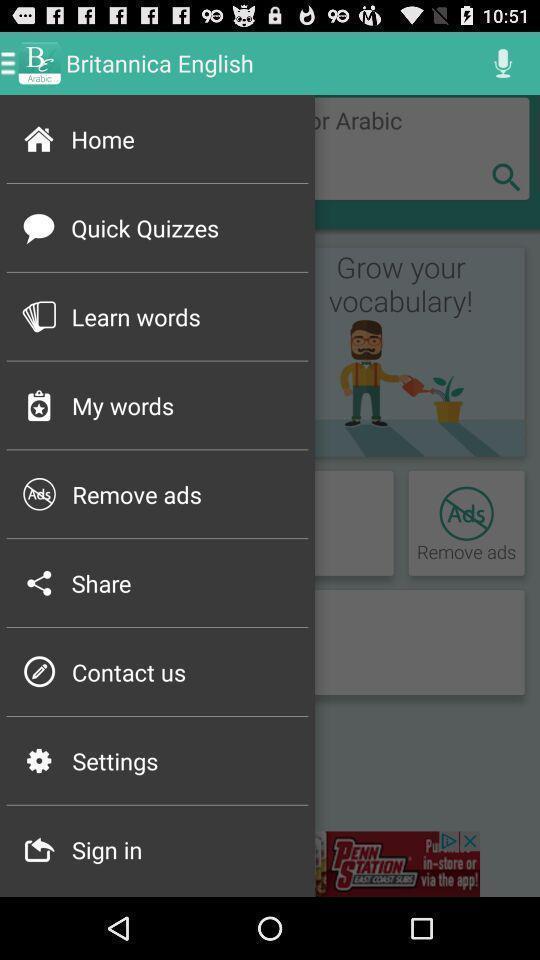What details can you identify in this image? Pop up showing different menu options. 